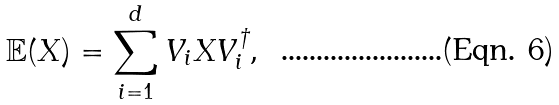<formula> <loc_0><loc_0><loc_500><loc_500>\mathbb { E } ( X ) = \sum _ { i = 1 } ^ { d } V _ { i } X V ^ { \dagger } _ { i } ,</formula> 